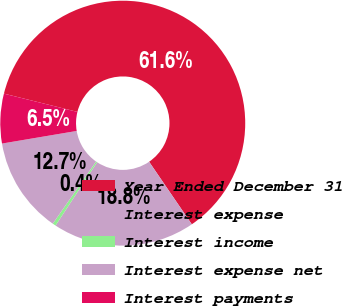<chart> <loc_0><loc_0><loc_500><loc_500><pie_chart><fcel>Year Ended December 31<fcel>Interest expense<fcel>Interest income<fcel>Interest expense net<fcel>Interest payments<nl><fcel>61.59%<fcel>18.78%<fcel>0.43%<fcel>12.66%<fcel>6.54%<nl></chart> 